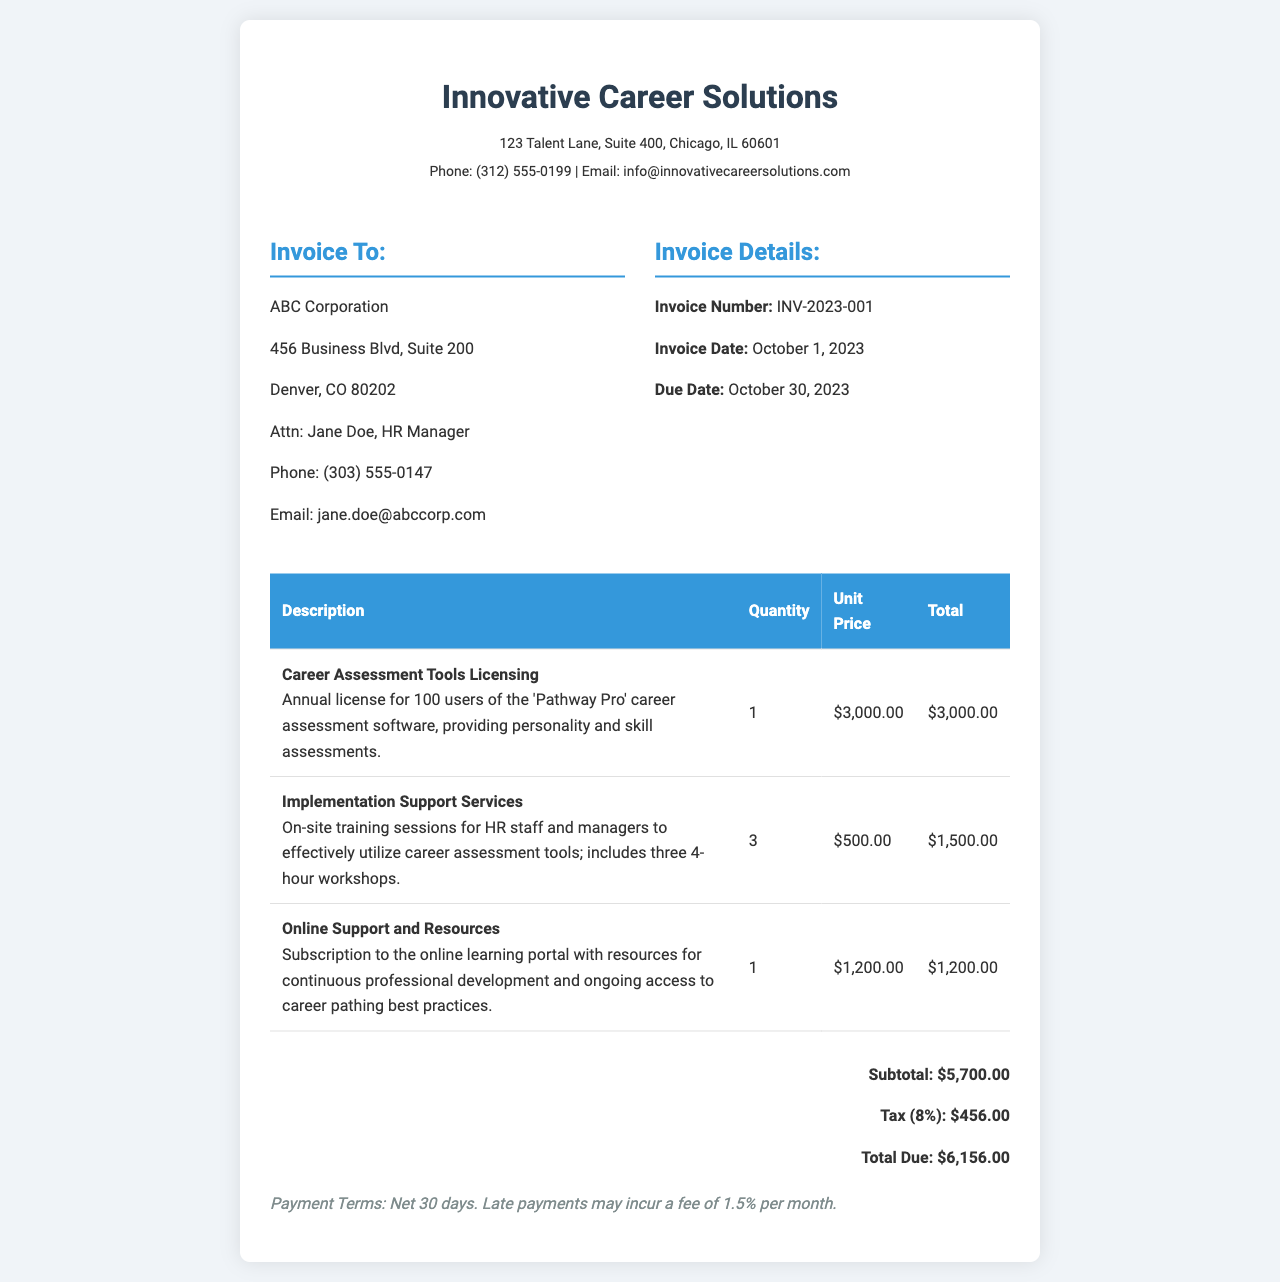What is the invoice number? The invoice number is clearly stated in the invoice details section, which identifies the specific invoice being discussed.
Answer: INV-2023-001 What is the total due amount? The total due amount is calculated and presented at the end of the invoice, summarizing all charges including tax.
Answer: $6,156.00 How many users are licensed for the career assessment tools? The document specifies the number of users included in the licensing for the career assessment tools, which is indicated in the description of the item.
Answer: 100 What is the price of the online support and resources? The price for the online support and resources is stated in the table for easy reference.
Answer: $1,200.00 What is the tax rate applied to the invoice? The tax rate is outlined in the financial summary, showing the percentage charged on the subtotal.
Answer: 8% How many implementation support services sessions are included? The quantity of implementation support services provided reflects the number of sessions mentioned within the description of that item.
Answer: 3 What is the payment term specified? Payment terms are usually stated in the invoice; here, it specifies the timeframe for payment and consequences for late payment.
Answer: Net 30 days What is the subtotal before tax? The subtotal before tax is presented in the total summary section, summarizing all cost items excluding tax.
Answer: $5,700.00 What is the address of Innovative Career Solutions? The address is included in the header section, providing the location of the company issuing the invoice.
Answer: 123 Talent Lane, Suite 400, Chicago, IL 60601 